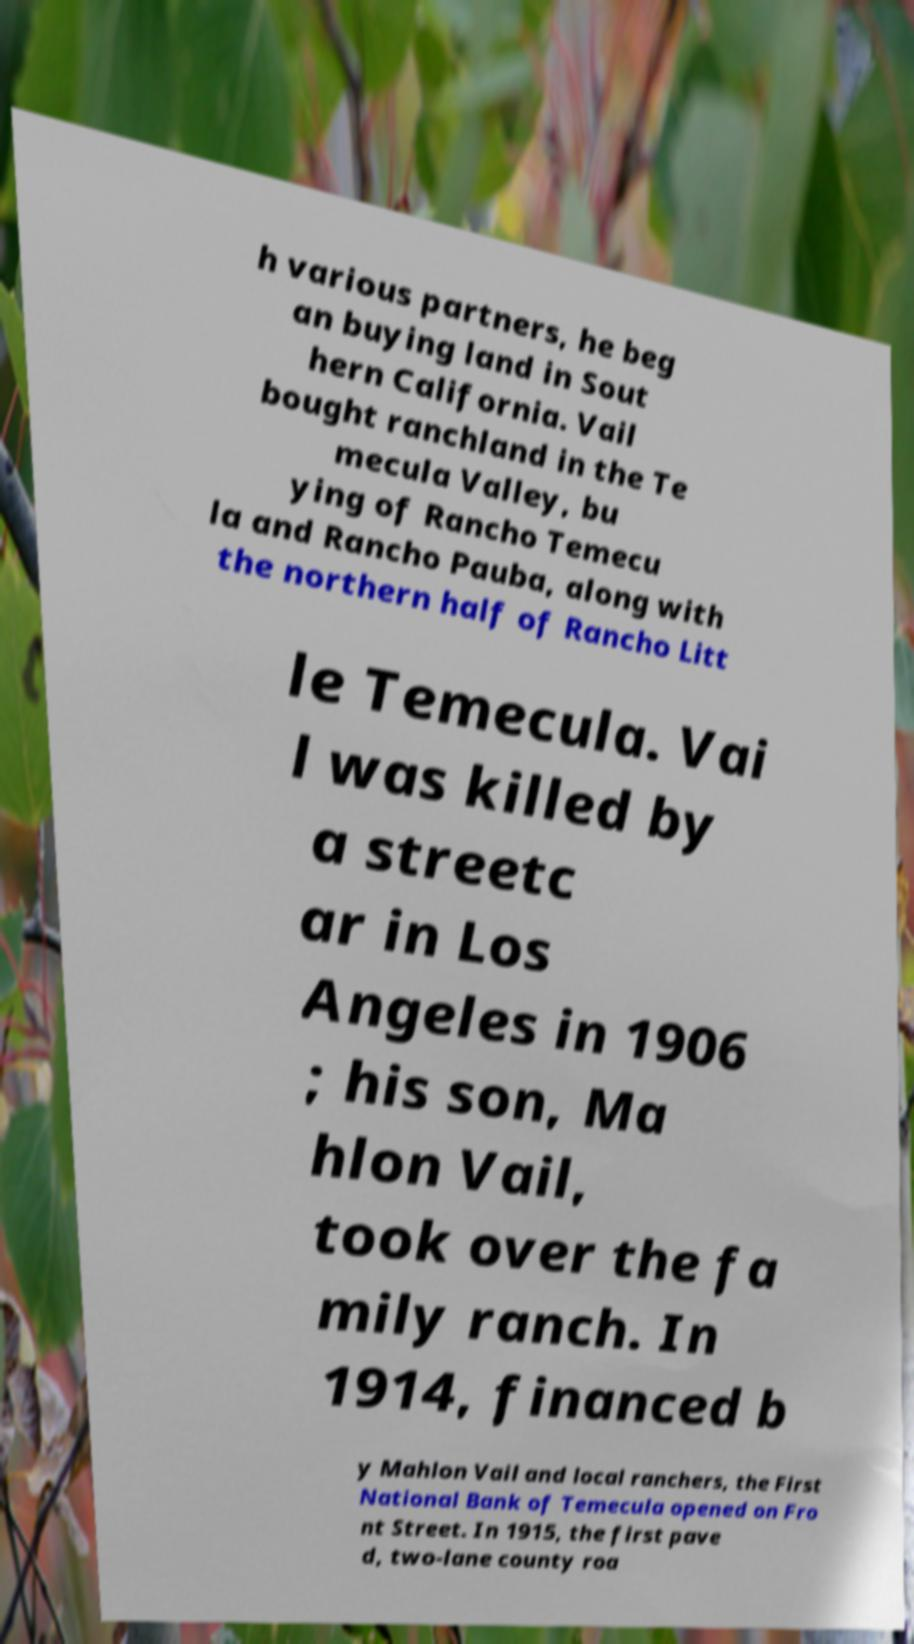Can you accurately transcribe the text from the provided image for me? h various partners, he beg an buying land in Sout hern California. Vail bought ranchland in the Te mecula Valley, bu ying of Rancho Temecu la and Rancho Pauba, along with the northern half of Rancho Litt le Temecula. Vai l was killed by a streetc ar in Los Angeles in 1906 ; his son, Ma hlon Vail, took over the fa mily ranch. In 1914, financed b y Mahlon Vail and local ranchers, the First National Bank of Temecula opened on Fro nt Street. In 1915, the first pave d, two-lane county roa 